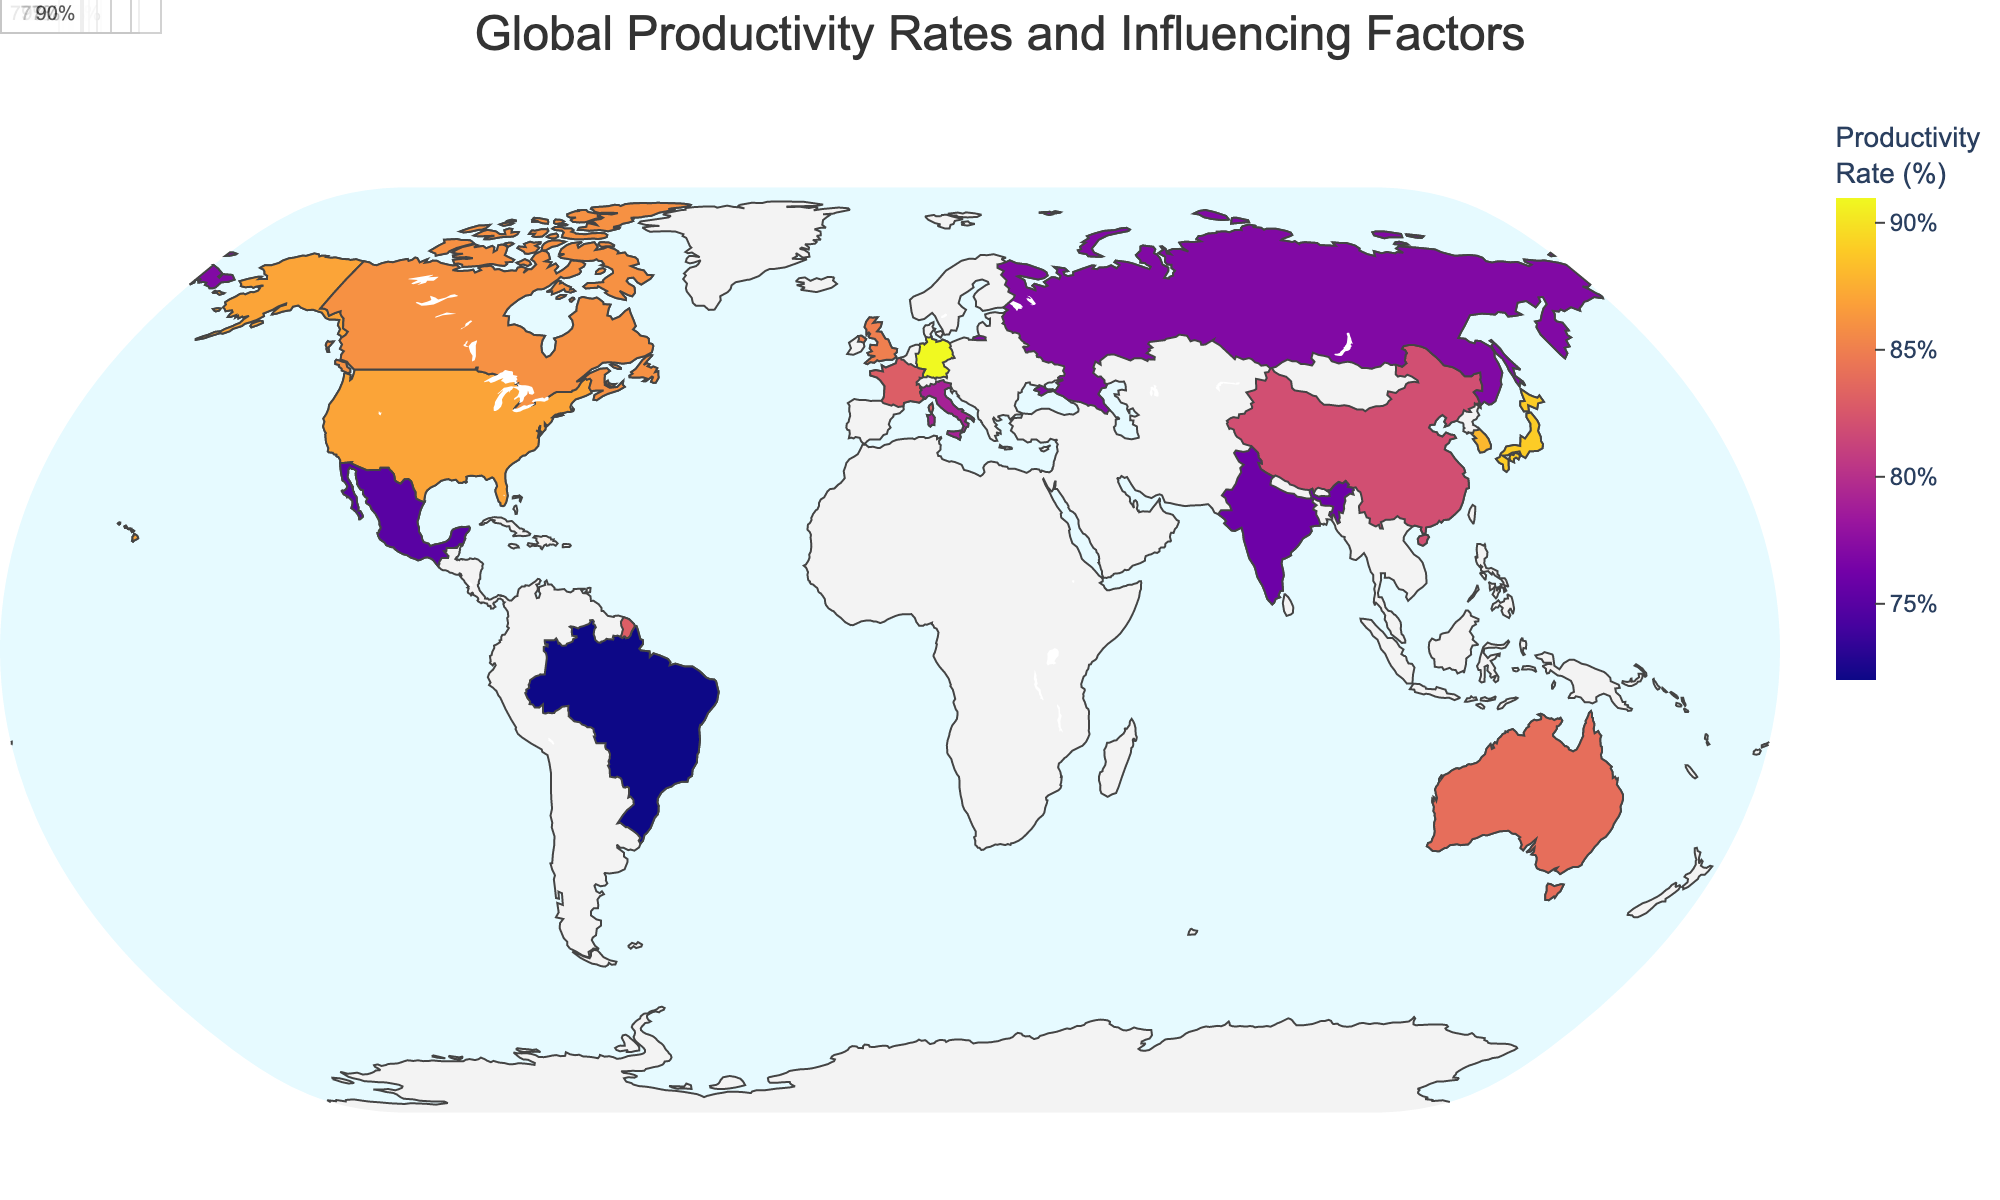What is the title of the figure? The title of the figure is displayed at the top and provides a summary of the plot. Reading the text at the top center of the figure reveals the title.
Answer: Global Productivity Rates and Influencing Factors Which region has the highest productivity rate? To determine the region with the highest productivity rate, look for the region with the darkest color or hover over the data points for exact values. Check the color legend to find the highest productivity value, then find the matching region.
Answer: Germany What are the main influencing factors for productivity in Japan? Hover over or click on the data point for Japan on the map. The pop-up information will show the main and secondary influencing factors.
Answer: Work Ethic How does the productivity rate of India compare to Brazil? Identify the productivity rates for India and Brazil by checking the respective countries on the map. India's rate is 76, and Brazil's rate is 72. India has a higher productivity rate than Brazil.
Answer: India has a higher rate What is the median productivity rate across all regions? List all productivity rates: 87, 82, 91, 89, 76, 72, 85, 88, 83, 86, 84, 75, 79, 77, 90. Arrange them in ascending order: 72, 75, 76, 77, 79, 82, 83, 84, 85, 86, 87, 88, 89, 90, 91. The median is the middle value in the list.
Answer: 84 Which two regions have productivity rates closest to each other? Compare productivity rates visually or by checking the data. Look for regions with the smallest difference in values. Canada (86) and United Kingdom (85) have productivity rates closest to each other.
Answer: Canada and United Kingdom What is the main influencing factor for productivity in the United Kingdom? Hover over or click on the data point for the United Kingdom on the map. The pop-up information will show the main influencing factors.
Answer: Strong Service Sector By how much does Germany's productivity rate exceed France's? Determine Germany's and France's productivity rates by checking their data points. Germany has a rate of 91, and France has 83. Subtract France's rate from Germany's.
Answer: 8% Which region has the lowest productivity rate and what are its influencing factors? Check the color legend for the lightest color indicating the lowest productivity rate. Find the matching region and its influencing factors by hovering over the data point. Brazil has the lowest rate of 72, with Natural Resources and Improving Education as its influencing factors.
Answer: Brazil, Natural Resources and Improving Education 